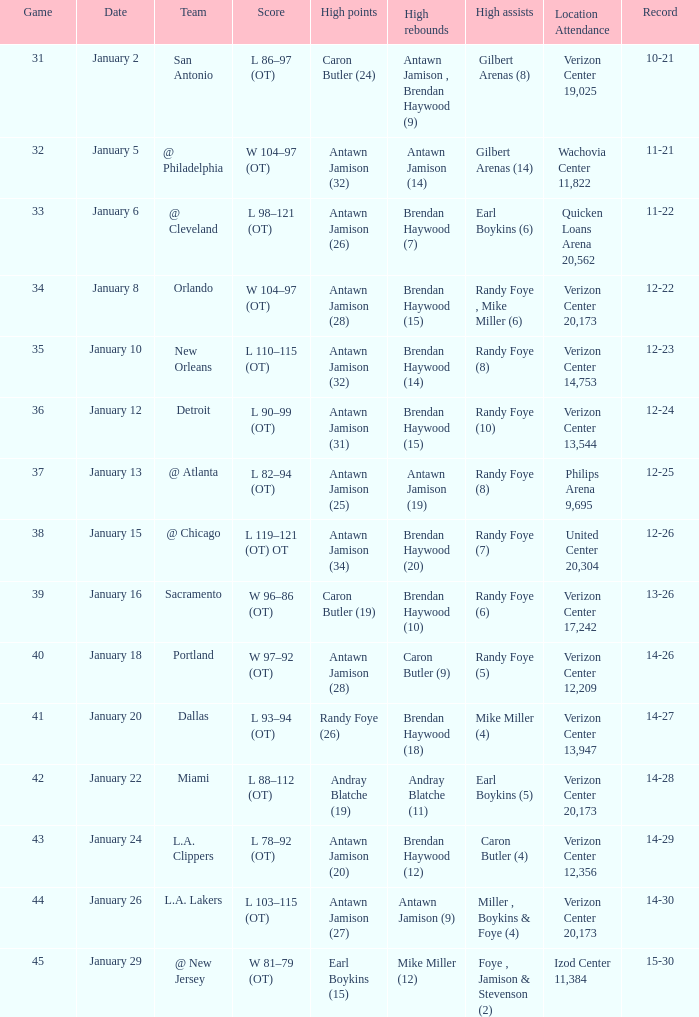In game 35, what was the number of individuals who scored high points? 1.0. Can you give me this table as a dict? {'header': ['Game', 'Date', 'Team', 'Score', 'High points', 'High rebounds', 'High assists', 'Location Attendance', 'Record'], 'rows': [['31', 'January 2', 'San Antonio', 'L 86–97 (OT)', 'Caron Butler (24)', 'Antawn Jamison , Brendan Haywood (9)', 'Gilbert Arenas (8)', 'Verizon Center 19,025', '10-21'], ['32', 'January 5', '@ Philadelphia', 'W 104–97 (OT)', 'Antawn Jamison (32)', 'Antawn Jamison (14)', 'Gilbert Arenas (14)', 'Wachovia Center 11,822', '11-21'], ['33', 'January 6', '@ Cleveland', 'L 98–121 (OT)', 'Antawn Jamison (26)', 'Brendan Haywood (7)', 'Earl Boykins (6)', 'Quicken Loans Arena 20,562', '11-22'], ['34', 'January 8', 'Orlando', 'W 104–97 (OT)', 'Antawn Jamison (28)', 'Brendan Haywood (15)', 'Randy Foye , Mike Miller (6)', 'Verizon Center 20,173', '12-22'], ['35', 'January 10', 'New Orleans', 'L 110–115 (OT)', 'Antawn Jamison (32)', 'Brendan Haywood (14)', 'Randy Foye (8)', 'Verizon Center 14,753', '12-23'], ['36', 'January 12', 'Detroit', 'L 90–99 (OT)', 'Antawn Jamison (31)', 'Brendan Haywood (15)', 'Randy Foye (10)', 'Verizon Center 13,544', '12-24'], ['37', 'January 13', '@ Atlanta', 'L 82–94 (OT)', 'Antawn Jamison (25)', 'Antawn Jamison (19)', 'Randy Foye (8)', 'Philips Arena 9,695', '12-25'], ['38', 'January 15', '@ Chicago', 'L 119–121 (OT) OT', 'Antawn Jamison (34)', 'Brendan Haywood (20)', 'Randy Foye (7)', 'United Center 20,304', '12-26'], ['39', 'January 16', 'Sacramento', 'W 96–86 (OT)', 'Caron Butler (19)', 'Brendan Haywood (10)', 'Randy Foye (6)', 'Verizon Center 17,242', '13-26'], ['40', 'January 18', 'Portland', 'W 97–92 (OT)', 'Antawn Jamison (28)', 'Caron Butler (9)', 'Randy Foye (5)', 'Verizon Center 12,209', '14-26'], ['41', 'January 20', 'Dallas', 'L 93–94 (OT)', 'Randy Foye (26)', 'Brendan Haywood (18)', 'Mike Miller (4)', 'Verizon Center 13,947', '14-27'], ['42', 'January 22', 'Miami', 'L 88–112 (OT)', 'Andray Blatche (19)', 'Andray Blatche (11)', 'Earl Boykins (5)', 'Verizon Center 20,173', '14-28'], ['43', 'January 24', 'L.A. Clippers', 'L 78–92 (OT)', 'Antawn Jamison (20)', 'Brendan Haywood (12)', 'Caron Butler (4)', 'Verizon Center 12,356', '14-29'], ['44', 'January 26', 'L.A. Lakers', 'L 103–115 (OT)', 'Antawn Jamison (27)', 'Antawn Jamison (9)', 'Miller , Boykins & Foye (4)', 'Verizon Center 20,173', '14-30'], ['45', 'January 29', '@ New Jersey', 'W 81–79 (OT)', 'Earl Boykins (15)', 'Mike Miller (12)', 'Foye , Jamison & Stevenson (2)', 'Izod Center 11,384', '15-30']]} 